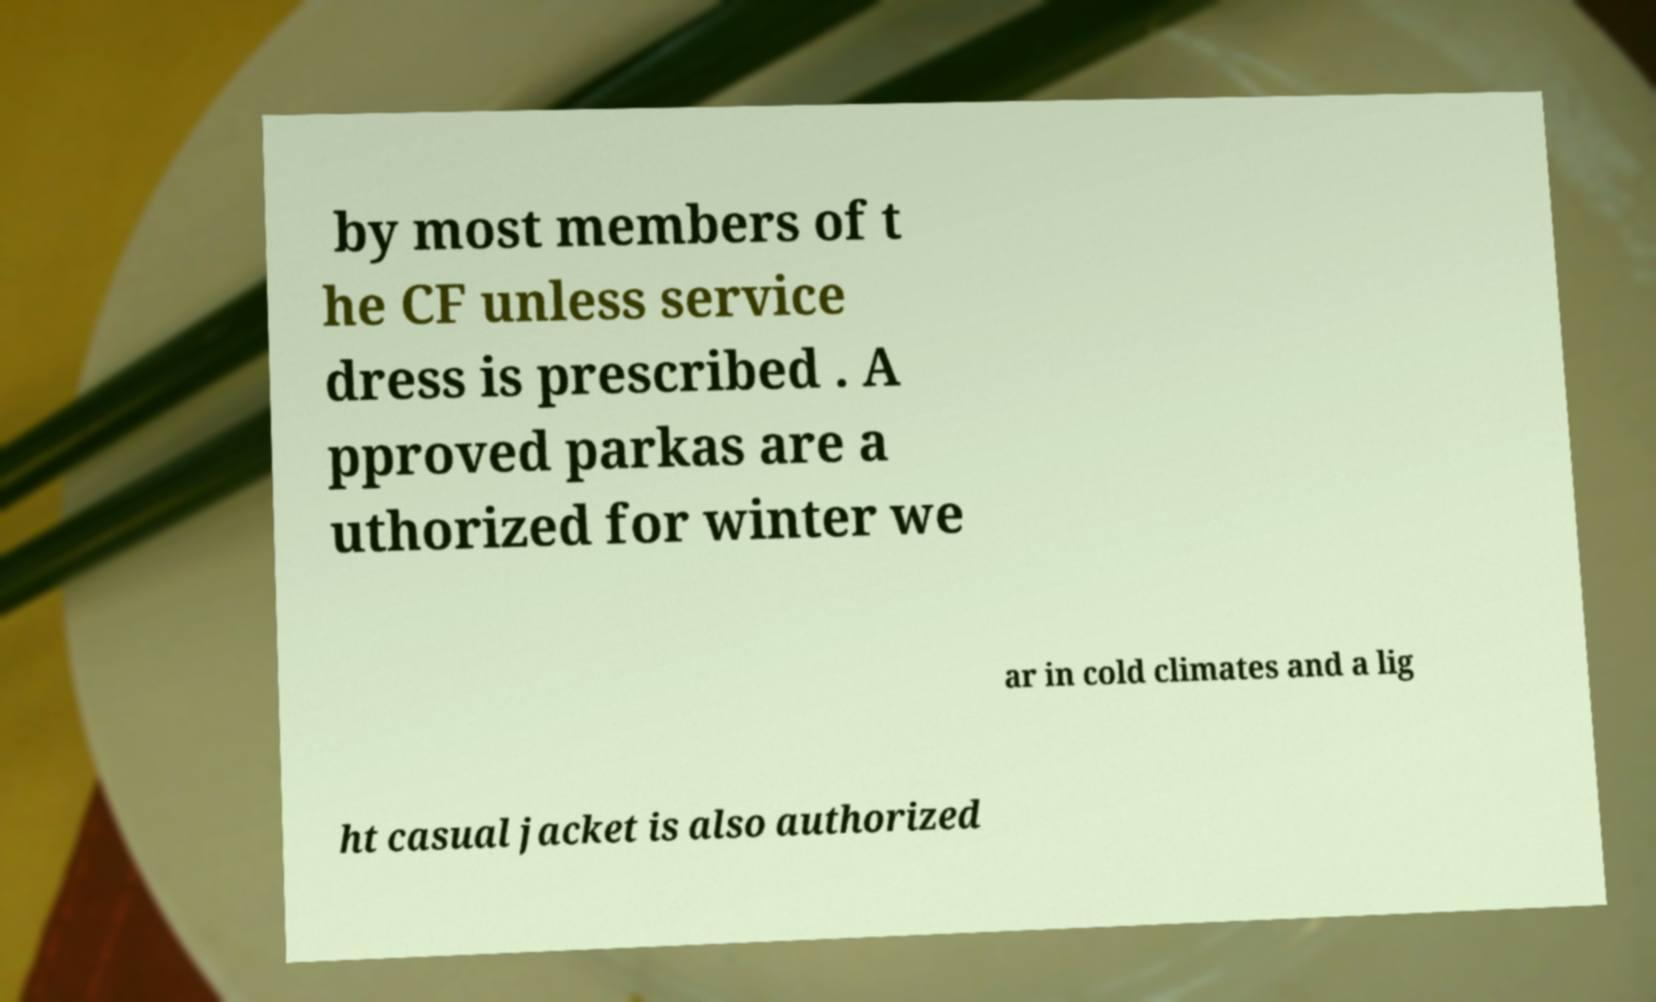I need the written content from this picture converted into text. Can you do that? by most members of t he CF unless service dress is prescribed . A pproved parkas are a uthorized for winter we ar in cold climates and a lig ht casual jacket is also authorized 